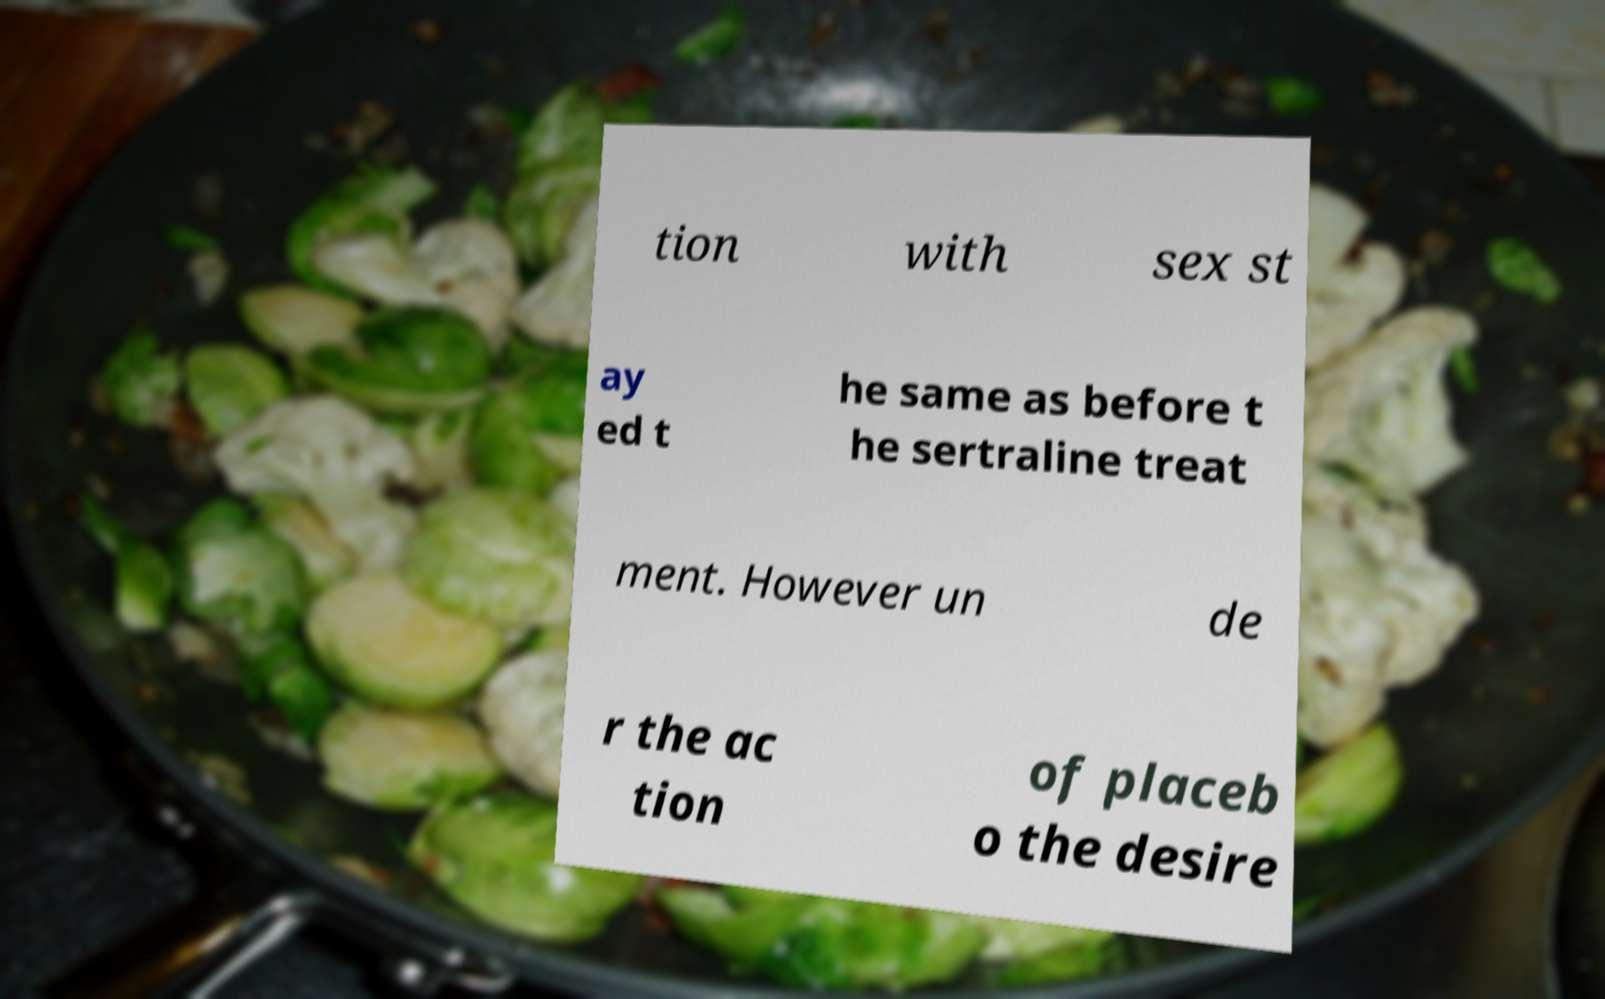Could you assist in decoding the text presented in this image and type it out clearly? tion with sex st ay ed t he same as before t he sertraline treat ment. However un de r the ac tion of placeb o the desire 